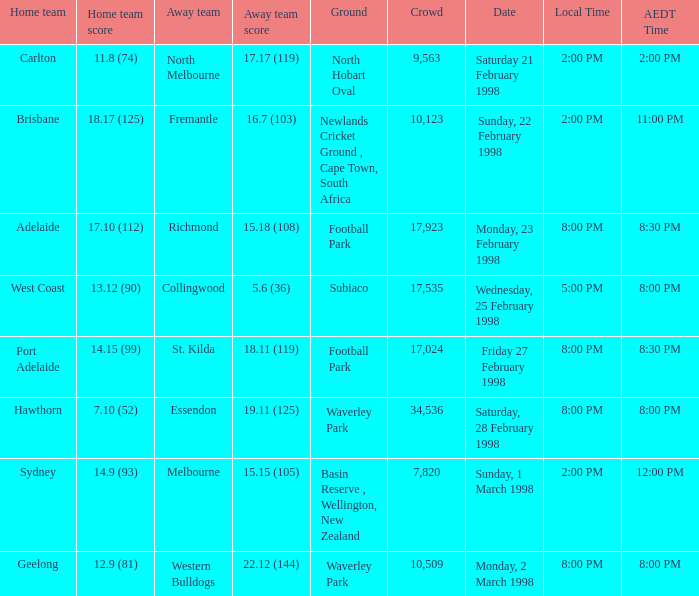What is the away team that uses waverley park as their ground and has hawthorn as their home team? Essendon. 